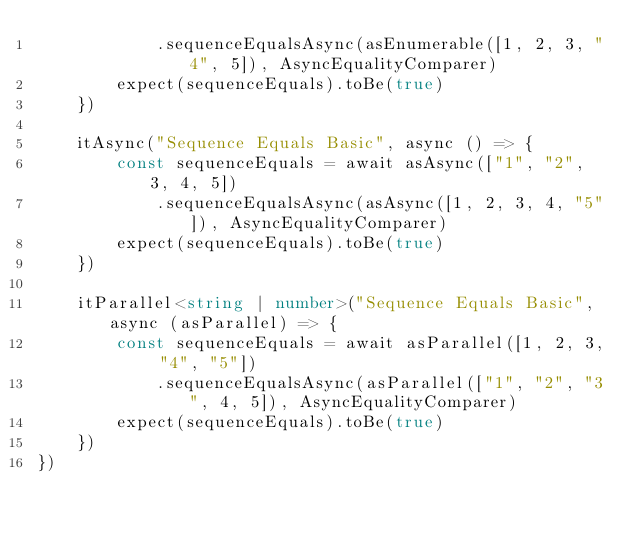Convert code to text. <code><loc_0><loc_0><loc_500><loc_500><_TypeScript_>            .sequenceEqualsAsync(asEnumerable([1, 2, 3, "4", 5]), AsyncEqualityComparer)
        expect(sequenceEquals).toBe(true)
    })

    itAsync("Sequence Equals Basic", async () => {
        const sequenceEquals = await asAsync(["1", "2", 3, 4, 5])
            .sequenceEqualsAsync(asAsync([1, 2, 3, 4, "5"]), AsyncEqualityComparer)
        expect(sequenceEquals).toBe(true)
    })

    itParallel<string | number>("Sequence Equals Basic", async (asParallel) => {
        const sequenceEquals = await asParallel([1, 2, 3, "4", "5"])
            .sequenceEqualsAsync(asParallel(["1", "2", "3", 4, 5]), AsyncEqualityComparer)
        expect(sequenceEquals).toBe(true)
    })
})
</code> 